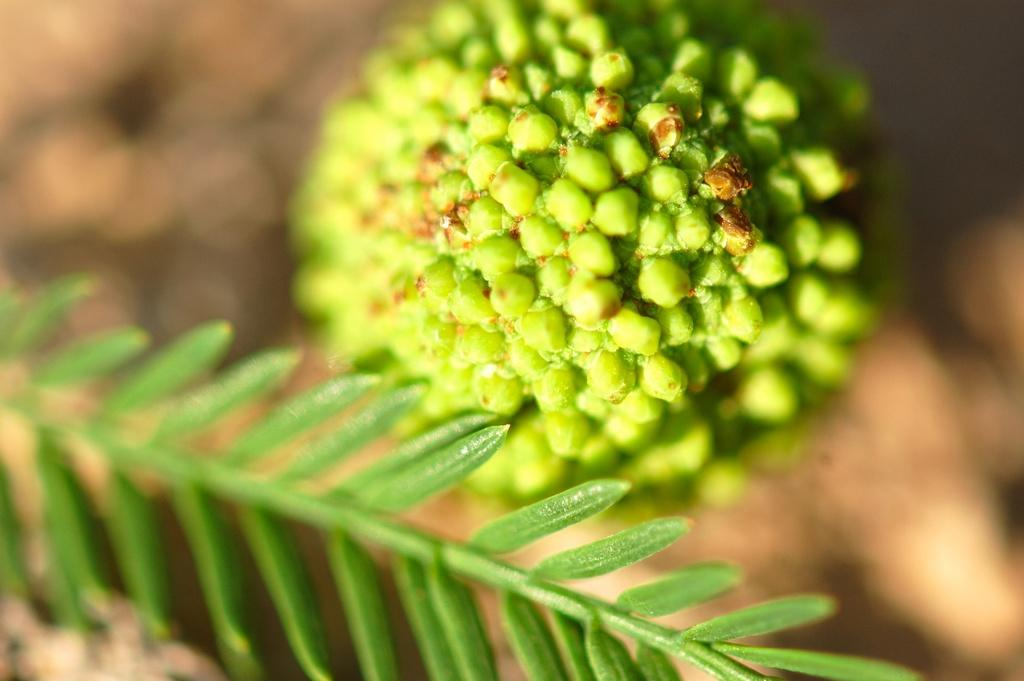What is the main subject of the image? There is a plant in the image. Where is the plant located in the image? The plant is at the center of the image. What else can be seen in the image besides the plant? There is fruit in the image. How is the fruit positioned in relation to the plant? The fruit is beside the plant. What type of soda is being stored on the shelf in the image? There is no shelf or soda present in the image. 